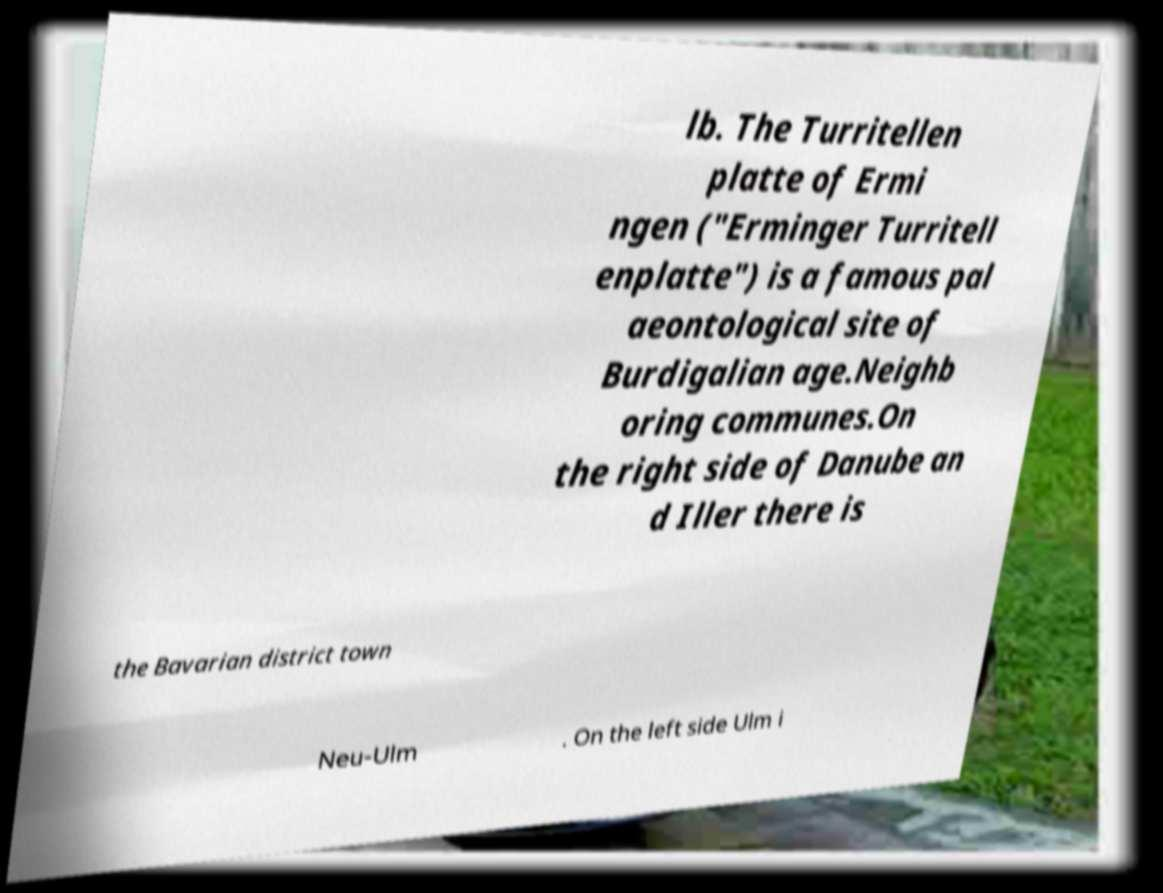There's text embedded in this image that I need extracted. Can you transcribe it verbatim? lb. The Turritellen platte of Ermi ngen ("Erminger Turritell enplatte") is a famous pal aeontological site of Burdigalian age.Neighb oring communes.On the right side of Danube an d Iller there is the Bavarian district town Neu-Ulm . On the left side Ulm i 